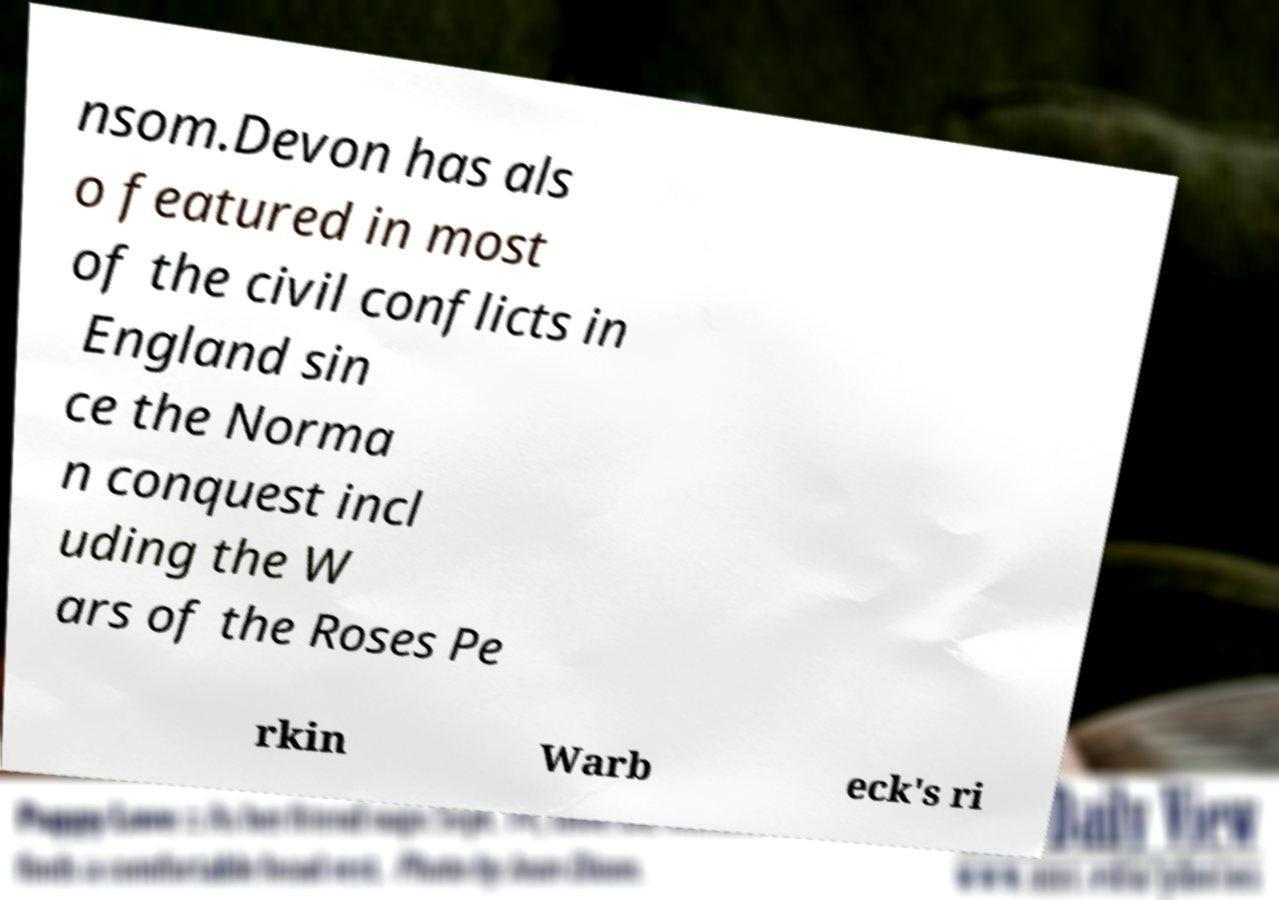Could you assist in decoding the text presented in this image and type it out clearly? nsom.Devon has als o featured in most of the civil conflicts in England sin ce the Norma n conquest incl uding the W ars of the Roses Pe rkin Warb eck's ri 